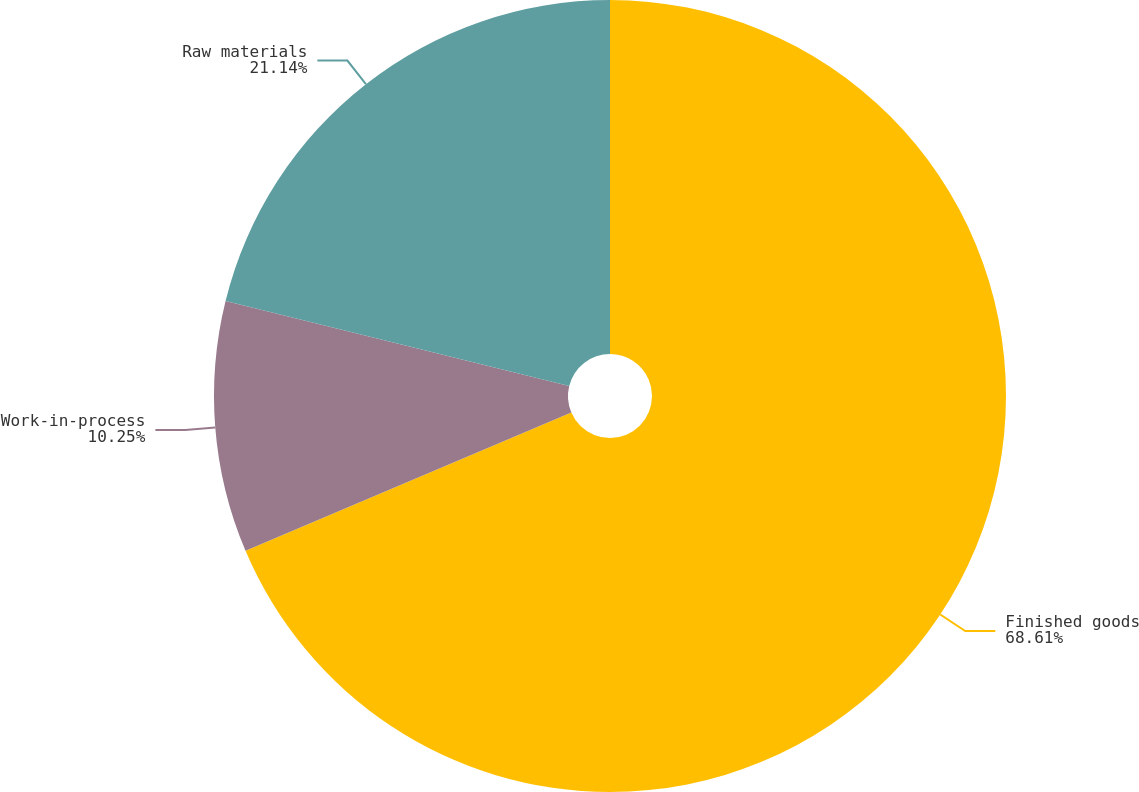Convert chart. <chart><loc_0><loc_0><loc_500><loc_500><pie_chart><fcel>Finished goods<fcel>Work-in-process<fcel>Raw materials<nl><fcel>68.6%<fcel>10.25%<fcel>21.14%<nl></chart> 